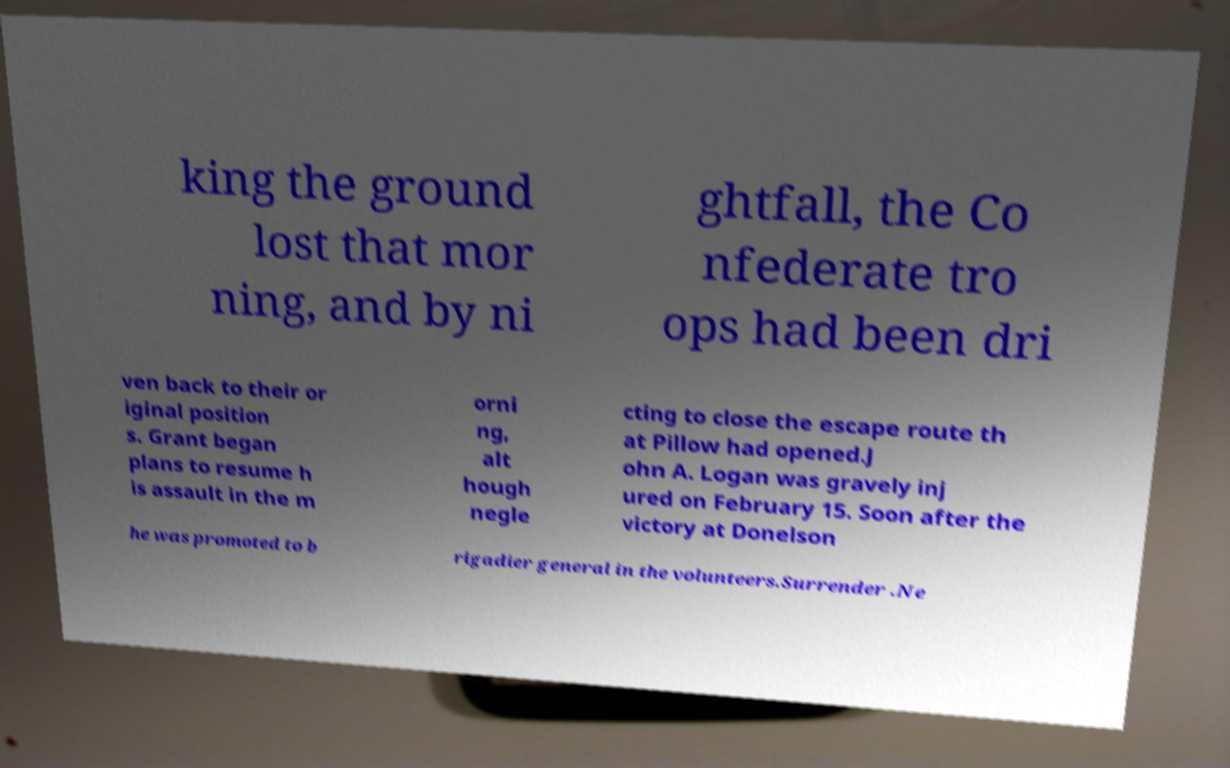I need the written content from this picture converted into text. Can you do that? king the ground lost that mor ning, and by ni ghtfall, the Co nfederate tro ops had been dri ven back to their or iginal position s. Grant began plans to resume h is assault in the m orni ng, alt hough negle cting to close the escape route th at Pillow had opened.J ohn A. Logan was gravely inj ured on February 15. Soon after the victory at Donelson he was promoted to b rigadier general in the volunteers.Surrender .Ne 